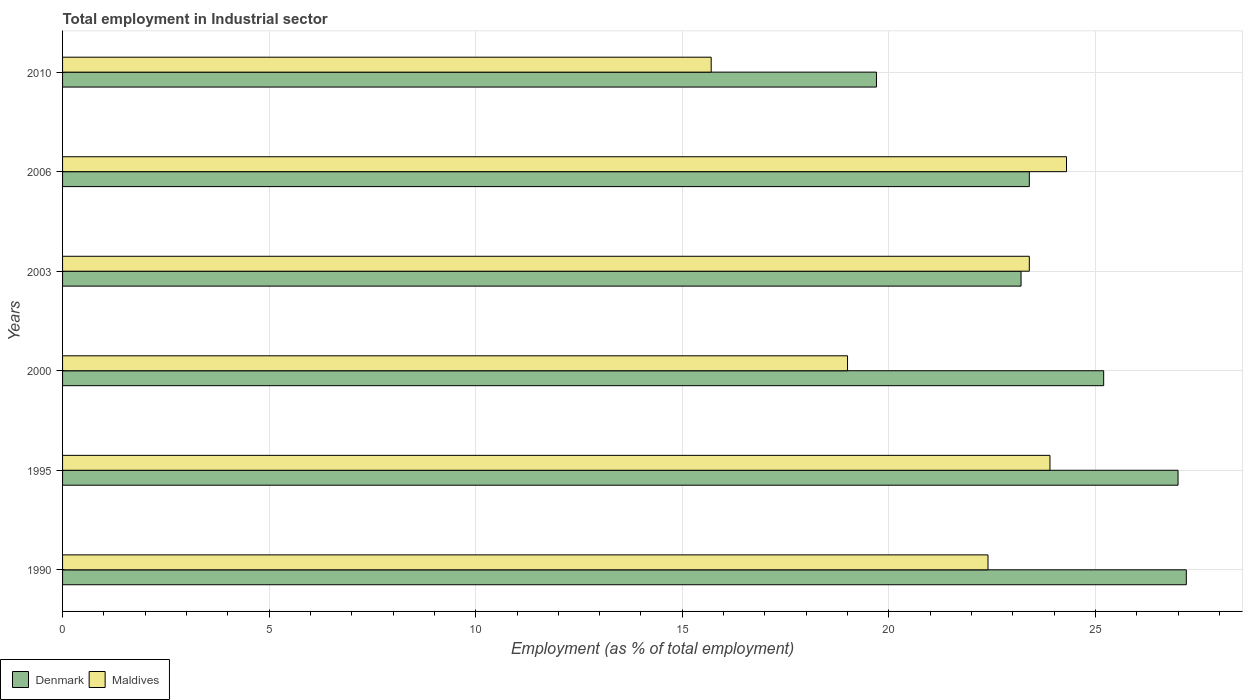How many groups of bars are there?
Provide a short and direct response. 6. Are the number of bars per tick equal to the number of legend labels?
Provide a succinct answer. Yes. Are the number of bars on each tick of the Y-axis equal?
Your answer should be very brief. Yes. How many bars are there on the 3rd tick from the top?
Your response must be concise. 2. In how many cases, is the number of bars for a given year not equal to the number of legend labels?
Offer a very short reply. 0. What is the employment in industrial sector in Denmark in 2006?
Make the answer very short. 23.4. Across all years, what is the maximum employment in industrial sector in Maldives?
Your answer should be compact. 24.3. Across all years, what is the minimum employment in industrial sector in Denmark?
Your response must be concise. 19.7. In which year was the employment in industrial sector in Denmark maximum?
Give a very brief answer. 1990. In which year was the employment in industrial sector in Maldives minimum?
Your answer should be very brief. 2010. What is the total employment in industrial sector in Denmark in the graph?
Offer a very short reply. 145.7. What is the difference between the employment in industrial sector in Maldives in 1995 and that in 2006?
Make the answer very short. -0.4. What is the difference between the employment in industrial sector in Denmark in 2000 and the employment in industrial sector in Maldives in 2003?
Provide a short and direct response. 1.8. What is the average employment in industrial sector in Denmark per year?
Provide a succinct answer. 24.28. In the year 2006, what is the difference between the employment in industrial sector in Maldives and employment in industrial sector in Denmark?
Your answer should be compact. 0.9. What is the ratio of the employment in industrial sector in Maldives in 2006 to that in 2010?
Provide a short and direct response. 1.55. Is the employment in industrial sector in Denmark in 1990 less than that in 2003?
Make the answer very short. No. Is the difference between the employment in industrial sector in Maldives in 1990 and 2003 greater than the difference between the employment in industrial sector in Denmark in 1990 and 2003?
Your response must be concise. No. What is the difference between the highest and the second highest employment in industrial sector in Maldives?
Your response must be concise. 0.4. What is the difference between the highest and the lowest employment in industrial sector in Maldives?
Offer a very short reply. 8.6. What does the 2nd bar from the top in 2000 represents?
Ensure brevity in your answer.  Denmark. Are all the bars in the graph horizontal?
Your answer should be compact. Yes. How many years are there in the graph?
Provide a succinct answer. 6. What is the difference between two consecutive major ticks on the X-axis?
Provide a succinct answer. 5. Does the graph contain grids?
Make the answer very short. Yes. How many legend labels are there?
Your answer should be compact. 2. How are the legend labels stacked?
Give a very brief answer. Horizontal. What is the title of the graph?
Ensure brevity in your answer.  Total employment in Industrial sector. Does "St. Lucia" appear as one of the legend labels in the graph?
Make the answer very short. No. What is the label or title of the X-axis?
Make the answer very short. Employment (as % of total employment). What is the label or title of the Y-axis?
Provide a short and direct response. Years. What is the Employment (as % of total employment) in Denmark in 1990?
Offer a very short reply. 27.2. What is the Employment (as % of total employment) of Maldives in 1990?
Your answer should be very brief. 22.4. What is the Employment (as % of total employment) in Denmark in 1995?
Offer a very short reply. 27. What is the Employment (as % of total employment) of Maldives in 1995?
Offer a very short reply. 23.9. What is the Employment (as % of total employment) of Denmark in 2000?
Your answer should be very brief. 25.2. What is the Employment (as % of total employment) in Denmark in 2003?
Provide a succinct answer. 23.2. What is the Employment (as % of total employment) in Maldives in 2003?
Give a very brief answer. 23.4. What is the Employment (as % of total employment) in Denmark in 2006?
Make the answer very short. 23.4. What is the Employment (as % of total employment) of Maldives in 2006?
Ensure brevity in your answer.  24.3. What is the Employment (as % of total employment) in Denmark in 2010?
Ensure brevity in your answer.  19.7. What is the Employment (as % of total employment) in Maldives in 2010?
Give a very brief answer. 15.7. Across all years, what is the maximum Employment (as % of total employment) of Denmark?
Give a very brief answer. 27.2. Across all years, what is the maximum Employment (as % of total employment) of Maldives?
Give a very brief answer. 24.3. Across all years, what is the minimum Employment (as % of total employment) of Denmark?
Give a very brief answer. 19.7. Across all years, what is the minimum Employment (as % of total employment) in Maldives?
Offer a very short reply. 15.7. What is the total Employment (as % of total employment) in Denmark in the graph?
Offer a terse response. 145.7. What is the total Employment (as % of total employment) of Maldives in the graph?
Ensure brevity in your answer.  128.7. What is the difference between the Employment (as % of total employment) in Maldives in 1990 and that in 1995?
Give a very brief answer. -1.5. What is the difference between the Employment (as % of total employment) of Denmark in 1990 and that in 2000?
Make the answer very short. 2. What is the difference between the Employment (as % of total employment) in Maldives in 1990 and that in 2000?
Give a very brief answer. 3.4. What is the difference between the Employment (as % of total employment) of Maldives in 1990 and that in 2003?
Offer a terse response. -1. What is the difference between the Employment (as % of total employment) of Denmark in 1990 and that in 2006?
Make the answer very short. 3.8. What is the difference between the Employment (as % of total employment) in Denmark in 1990 and that in 2010?
Your answer should be very brief. 7.5. What is the difference between the Employment (as % of total employment) of Denmark in 1995 and that in 2000?
Provide a succinct answer. 1.8. What is the difference between the Employment (as % of total employment) of Denmark in 1995 and that in 2010?
Keep it short and to the point. 7.3. What is the difference between the Employment (as % of total employment) of Denmark in 2000 and that in 2010?
Provide a succinct answer. 5.5. What is the difference between the Employment (as % of total employment) in Denmark in 2003 and that in 2006?
Your answer should be very brief. -0.2. What is the difference between the Employment (as % of total employment) in Maldives in 2003 and that in 2006?
Offer a very short reply. -0.9. What is the difference between the Employment (as % of total employment) of Maldives in 2003 and that in 2010?
Give a very brief answer. 7.7. What is the difference between the Employment (as % of total employment) in Denmark in 2006 and that in 2010?
Provide a succinct answer. 3.7. What is the difference between the Employment (as % of total employment) of Maldives in 2006 and that in 2010?
Offer a terse response. 8.6. What is the difference between the Employment (as % of total employment) of Denmark in 1990 and the Employment (as % of total employment) of Maldives in 2003?
Ensure brevity in your answer.  3.8. What is the difference between the Employment (as % of total employment) of Denmark in 1995 and the Employment (as % of total employment) of Maldives in 2003?
Keep it short and to the point. 3.6. What is the difference between the Employment (as % of total employment) of Denmark in 1995 and the Employment (as % of total employment) of Maldives in 2010?
Provide a short and direct response. 11.3. What is the average Employment (as % of total employment) in Denmark per year?
Offer a very short reply. 24.28. What is the average Employment (as % of total employment) in Maldives per year?
Offer a very short reply. 21.45. In the year 1990, what is the difference between the Employment (as % of total employment) in Denmark and Employment (as % of total employment) in Maldives?
Your response must be concise. 4.8. In the year 1995, what is the difference between the Employment (as % of total employment) of Denmark and Employment (as % of total employment) of Maldives?
Provide a short and direct response. 3.1. In the year 2000, what is the difference between the Employment (as % of total employment) of Denmark and Employment (as % of total employment) of Maldives?
Your response must be concise. 6.2. What is the ratio of the Employment (as % of total employment) of Denmark in 1990 to that in 1995?
Give a very brief answer. 1.01. What is the ratio of the Employment (as % of total employment) in Maldives in 1990 to that in 1995?
Your answer should be compact. 0.94. What is the ratio of the Employment (as % of total employment) in Denmark in 1990 to that in 2000?
Give a very brief answer. 1.08. What is the ratio of the Employment (as % of total employment) of Maldives in 1990 to that in 2000?
Your answer should be very brief. 1.18. What is the ratio of the Employment (as % of total employment) in Denmark in 1990 to that in 2003?
Keep it short and to the point. 1.17. What is the ratio of the Employment (as % of total employment) of Maldives in 1990 to that in 2003?
Keep it short and to the point. 0.96. What is the ratio of the Employment (as % of total employment) of Denmark in 1990 to that in 2006?
Your answer should be very brief. 1.16. What is the ratio of the Employment (as % of total employment) of Maldives in 1990 to that in 2006?
Your answer should be very brief. 0.92. What is the ratio of the Employment (as % of total employment) of Denmark in 1990 to that in 2010?
Offer a very short reply. 1.38. What is the ratio of the Employment (as % of total employment) of Maldives in 1990 to that in 2010?
Provide a short and direct response. 1.43. What is the ratio of the Employment (as % of total employment) of Denmark in 1995 to that in 2000?
Your answer should be compact. 1.07. What is the ratio of the Employment (as % of total employment) of Maldives in 1995 to that in 2000?
Ensure brevity in your answer.  1.26. What is the ratio of the Employment (as % of total employment) in Denmark in 1995 to that in 2003?
Your answer should be compact. 1.16. What is the ratio of the Employment (as % of total employment) in Maldives in 1995 to that in 2003?
Provide a succinct answer. 1.02. What is the ratio of the Employment (as % of total employment) in Denmark in 1995 to that in 2006?
Offer a terse response. 1.15. What is the ratio of the Employment (as % of total employment) of Maldives in 1995 to that in 2006?
Your answer should be very brief. 0.98. What is the ratio of the Employment (as % of total employment) of Denmark in 1995 to that in 2010?
Offer a very short reply. 1.37. What is the ratio of the Employment (as % of total employment) of Maldives in 1995 to that in 2010?
Offer a terse response. 1.52. What is the ratio of the Employment (as % of total employment) in Denmark in 2000 to that in 2003?
Ensure brevity in your answer.  1.09. What is the ratio of the Employment (as % of total employment) of Maldives in 2000 to that in 2003?
Provide a short and direct response. 0.81. What is the ratio of the Employment (as % of total employment) of Denmark in 2000 to that in 2006?
Your answer should be compact. 1.08. What is the ratio of the Employment (as % of total employment) of Maldives in 2000 to that in 2006?
Provide a succinct answer. 0.78. What is the ratio of the Employment (as % of total employment) in Denmark in 2000 to that in 2010?
Give a very brief answer. 1.28. What is the ratio of the Employment (as % of total employment) of Maldives in 2000 to that in 2010?
Provide a succinct answer. 1.21. What is the ratio of the Employment (as % of total employment) in Denmark in 2003 to that in 2006?
Provide a succinct answer. 0.99. What is the ratio of the Employment (as % of total employment) in Denmark in 2003 to that in 2010?
Your answer should be very brief. 1.18. What is the ratio of the Employment (as % of total employment) of Maldives in 2003 to that in 2010?
Provide a succinct answer. 1.49. What is the ratio of the Employment (as % of total employment) in Denmark in 2006 to that in 2010?
Your answer should be very brief. 1.19. What is the ratio of the Employment (as % of total employment) of Maldives in 2006 to that in 2010?
Keep it short and to the point. 1.55. What is the difference between the highest and the second highest Employment (as % of total employment) in Denmark?
Provide a succinct answer. 0.2. What is the difference between the highest and the lowest Employment (as % of total employment) in Denmark?
Provide a short and direct response. 7.5. 